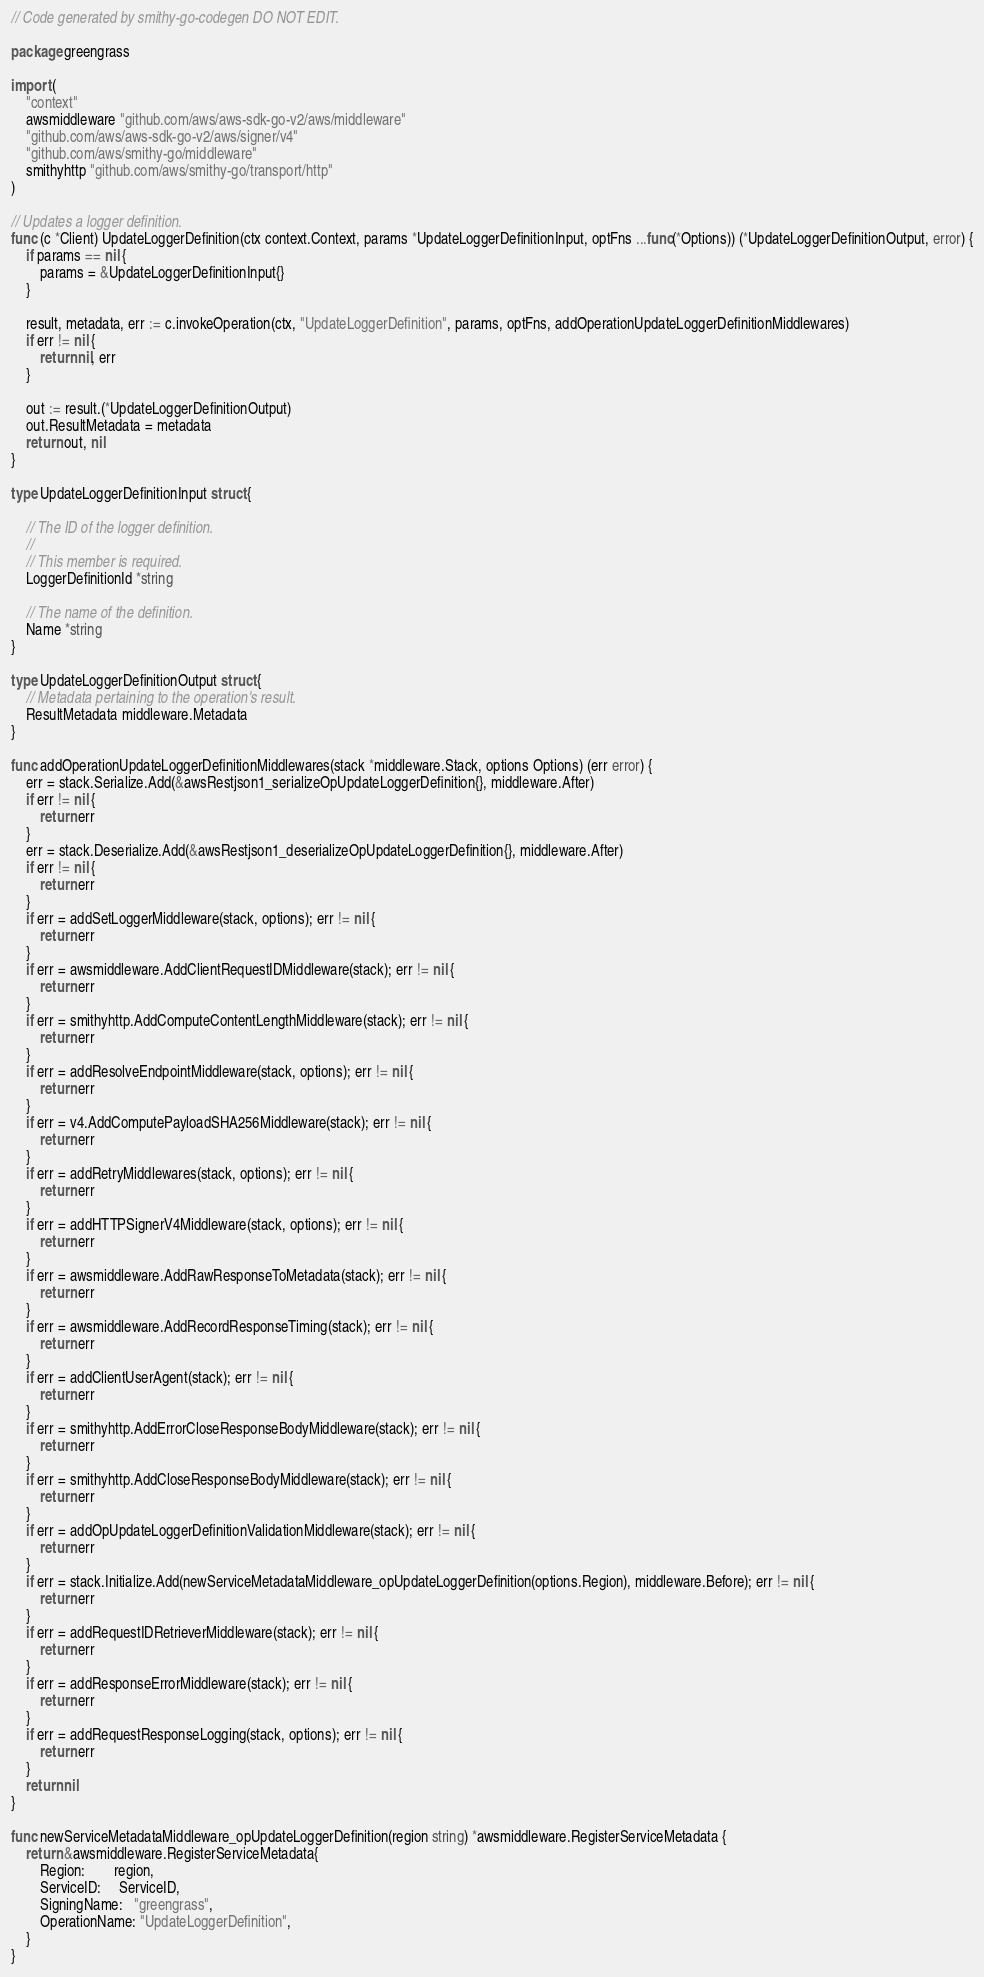<code> <loc_0><loc_0><loc_500><loc_500><_Go_>// Code generated by smithy-go-codegen DO NOT EDIT.

package greengrass

import (
	"context"
	awsmiddleware "github.com/aws/aws-sdk-go-v2/aws/middleware"
	"github.com/aws/aws-sdk-go-v2/aws/signer/v4"
	"github.com/aws/smithy-go/middleware"
	smithyhttp "github.com/aws/smithy-go/transport/http"
)

// Updates a logger definition.
func (c *Client) UpdateLoggerDefinition(ctx context.Context, params *UpdateLoggerDefinitionInput, optFns ...func(*Options)) (*UpdateLoggerDefinitionOutput, error) {
	if params == nil {
		params = &UpdateLoggerDefinitionInput{}
	}

	result, metadata, err := c.invokeOperation(ctx, "UpdateLoggerDefinition", params, optFns, addOperationUpdateLoggerDefinitionMiddlewares)
	if err != nil {
		return nil, err
	}

	out := result.(*UpdateLoggerDefinitionOutput)
	out.ResultMetadata = metadata
	return out, nil
}

type UpdateLoggerDefinitionInput struct {

	// The ID of the logger definition.
	//
	// This member is required.
	LoggerDefinitionId *string

	// The name of the definition.
	Name *string
}

type UpdateLoggerDefinitionOutput struct {
	// Metadata pertaining to the operation's result.
	ResultMetadata middleware.Metadata
}

func addOperationUpdateLoggerDefinitionMiddlewares(stack *middleware.Stack, options Options) (err error) {
	err = stack.Serialize.Add(&awsRestjson1_serializeOpUpdateLoggerDefinition{}, middleware.After)
	if err != nil {
		return err
	}
	err = stack.Deserialize.Add(&awsRestjson1_deserializeOpUpdateLoggerDefinition{}, middleware.After)
	if err != nil {
		return err
	}
	if err = addSetLoggerMiddleware(stack, options); err != nil {
		return err
	}
	if err = awsmiddleware.AddClientRequestIDMiddleware(stack); err != nil {
		return err
	}
	if err = smithyhttp.AddComputeContentLengthMiddleware(stack); err != nil {
		return err
	}
	if err = addResolveEndpointMiddleware(stack, options); err != nil {
		return err
	}
	if err = v4.AddComputePayloadSHA256Middleware(stack); err != nil {
		return err
	}
	if err = addRetryMiddlewares(stack, options); err != nil {
		return err
	}
	if err = addHTTPSignerV4Middleware(stack, options); err != nil {
		return err
	}
	if err = awsmiddleware.AddRawResponseToMetadata(stack); err != nil {
		return err
	}
	if err = awsmiddleware.AddRecordResponseTiming(stack); err != nil {
		return err
	}
	if err = addClientUserAgent(stack); err != nil {
		return err
	}
	if err = smithyhttp.AddErrorCloseResponseBodyMiddleware(stack); err != nil {
		return err
	}
	if err = smithyhttp.AddCloseResponseBodyMiddleware(stack); err != nil {
		return err
	}
	if err = addOpUpdateLoggerDefinitionValidationMiddleware(stack); err != nil {
		return err
	}
	if err = stack.Initialize.Add(newServiceMetadataMiddleware_opUpdateLoggerDefinition(options.Region), middleware.Before); err != nil {
		return err
	}
	if err = addRequestIDRetrieverMiddleware(stack); err != nil {
		return err
	}
	if err = addResponseErrorMiddleware(stack); err != nil {
		return err
	}
	if err = addRequestResponseLogging(stack, options); err != nil {
		return err
	}
	return nil
}

func newServiceMetadataMiddleware_opUpdateLoggerDefinition(region string) *awsmiddleware.RegisterServiceMetadata {
	return &awsmiddleware.RegisterServiceMetadata{
		Region:        region,
		ServiceID:     ServiceID,
		SigningName:   "greengrass",
		OperationName: "UpdateLoggerDefinition",
	}
}
</code> 